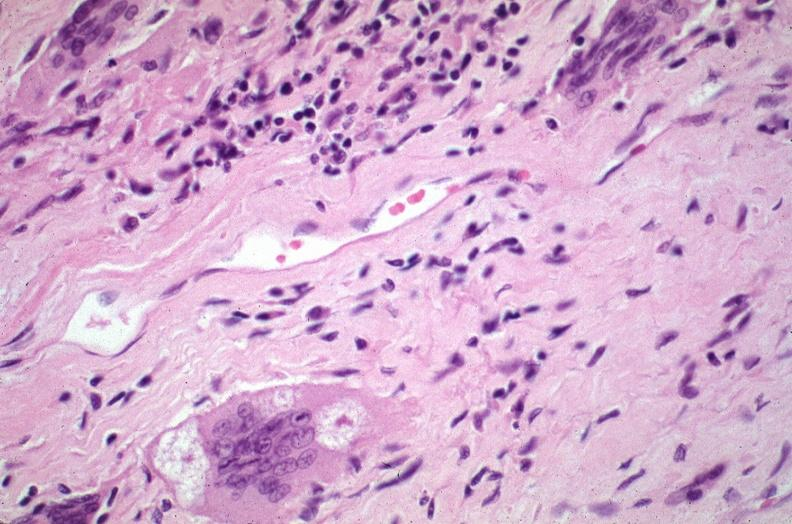what does this image show?
Answer the question using a single word or phrase. Lung 